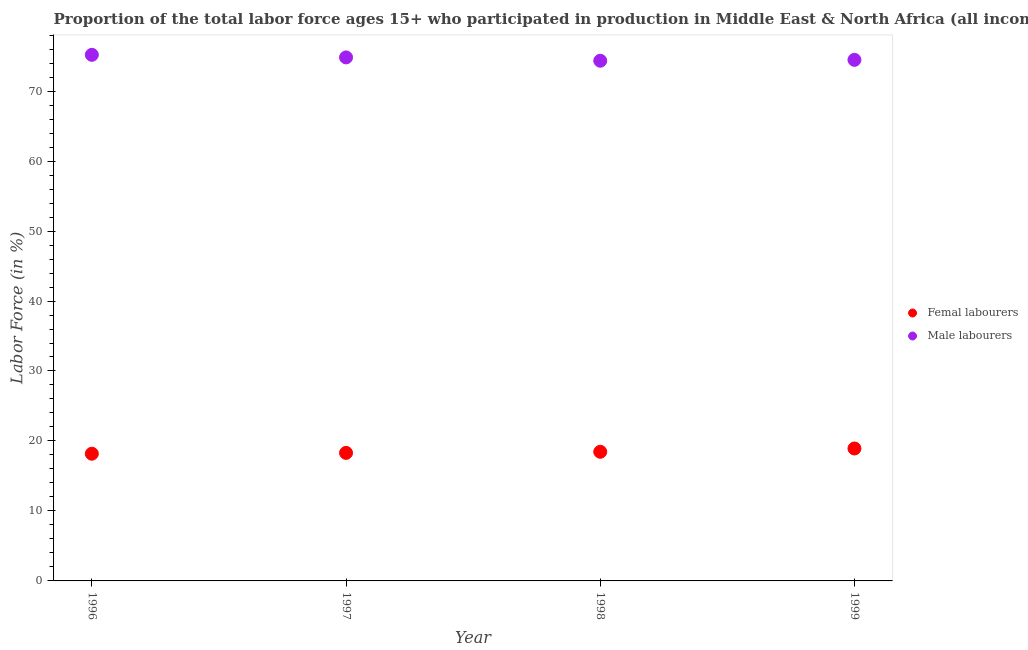Is the number of dotlines equal to the number of legend labels?
Provide a succinct answer. Yes. What is the percentage of female labor force in 1999?
Offer a very short reply. 18.93. Across all years, what is the maximum percentage of female labor force?
Ensure brevity in your answer.  18.93. Across all years, what is the minimum percentage of male labour force?
Provide a short and direct response. 74.34. In which year was the percentage of female labor force maximum?
Give a very brief answer. 1999. What is the total percentage of male labour force in the graph?
Offer a very short reply. 298.79. What is the difference between the percentage of female labor force in 1996 and that in 1998?
Ensure brevity in your answer.  -0.28. What is the difference between the percentage of female labor force in 1997 and the percentage of male labour force in 1999?
Offer a very short reply. -56.17. What is the average percentage of male labour force per year?
Make the answer very short. 74.7. In the year 1998, what is the difference between the percentage of male labour force and percentage of female labor force?
Make the answer very short. 55.88. What is the ratio of the percentage of male labour force in 1997 to that in 1998?
Provide a short and direct response. 1.01. Is the difference between the percentage of female labor force in 1996 and 1997 greater than the difference between the percentage of male labour force in 1996 and 1997?
Offer a very short reply. No. What is the difference between the highest and the second highest percentage of male labour force?
Your answer should be compact. 0.37. What is the difference between the highest and the lowest percentage of male labour force?
Provide a short and direct response. 0.85. Is the percentage of male labour force strictly greater than the percentage of female labor force over the years?
Your answer should be compact. Yes. How many dotlines are there?
Offer a very short reply. 2. Are the values on the major ticks of Y-axis written in scientific E-notation?
Make the answer very short. No. Does the graph contain any zero values?
Give a very brief answer. No. How many legend labels are there?
Provide a short and direct response. 2. What is the title of the graph?
Offer a terse response. Proportion of the total labor force ages 15+ who participated in production in Middle East & North Africa (all income levels). What is the label or title of the X-axis?
Ensure brevity in your answer.  Year. What is the Labor Force (in %) in Femal labourers in 1996?
Your answer should be compact. 18.18. What is the Labor Force (in %) in Male labourers in 1996?
Offer a terse response. 75.18. What is the Labor Force (in %) of Femal labourers in 1997?
Your answer should be compact. 18.3. What is the Labor Force (in %) of Male labourers in 1997?
Offer a terse response. 74.81. What is the Labor Force (in %) of Femal labourers in 1998?
Keep it short and to the point. 18.45. What is the Labor Force (in %) in Male labourers in 1998?
Offer a terse response. 74.34. What is the Labor Force (in %) in Femal labourers in 1999?
Your answer should be very brief. 18.93. What is the Labor Force (in %) of Male labourers in 1999?
Offer a terse response. 74.46. Across all years, what is the maximum Labor Force (in %) of Femal labourers?
Provide a short and direct response. 18.93. Across all years, what is the maximum Labor Force (in %) of Male labourers?
Make the answer very short. 75.18. Across all years, what is the minimum Labor Force (in %) of Femal labourers?
Your response must be concise. 18.18. Across all years, what is the minimum Labor Force (in %) in Male labourers?
Your response must be concise. 74.34. What is the total Labor Force (in %) in Femal labourers in the graph?
Make the answer very short. 73.86. What is the total Labor Force (in %) of Male labourers in the graph?
Provide a succinct answer. 298.79. What is the difference between the Labor Force (in %) of Femal labourers in 1996 and that in 1997?
Your answer should be compact. -0.12. What is the difference between the Labor Force (in %) of Male labourers in 1996 and that in 1997?
Provide a short and direct response. 0.37. What is the difference between the Labor Force (in %) of Femal labourers in 1996 and that in 1998?
Offer a terse response. -0.28. What is the difference between the Labor Force (in %) in Male labourers in 1996 and that in 1998?
Give a very brief answer. 0.85. What is the difference between the Labor Force (in %) in Femal labourers in 1996 and that in 1999?
Provide a succinct answer. -0.75. What is the difference between the Labor Force (in %) of Male labourers in 1996 and that in 1999?
Provide a short and direct response. 0.72. What is the difference between the Labor Force (in %) of Femal labourers in 1997 and that in 1998?
Your answer should be very brief. -0.16. What is the difference between the Labor Force (in %) of Male labourers in 1997 and that in 1998?
Make the answer very short. 0.48. What is the difference between the Labor Force (in %) in Femal labourers in 1997 and that in 1999?
Ensure brevity in your answer.  -0.63. What is the difference between the Labor Force (in %) of Male labourers in 1997 and that in 1999?
Offer a terse response. 0.35. What is the difference between the Labor Force (in %) of Femal labourers in 1998 and that in 1999?
Your answer should be compact. -0.47. What is the difference between the Labor Force (in %) of Male labourers in 1998 and that in 1999?
Provide a succinct answer. -0.13. What is the difference between the Labor Force (in %) in Femal labourers in 1996 and the Labor Force (in %) in Male labourers in 1997?
Your response must be concise. -56.63. What is the difference between the Labor Force (in %) in Femal labourers in 1996 and the Labor Force (in %) in Male labourers in 1998?
Make the answer very short. -56.16. What is the difference between the Labor Force (in %) of Femal labourers in 1996 and the Labor Force (in %) of Male labourers in 1999?
Offer a very short reply. -56.28. What is the difference between the Labor Force (in %) in Femal labourers in 1997 and the Labor Force (in %) in Male labourers in 1998?
Provide a short and direct response. -56.04. What is the difference between the Labor Force (in %) in Femal labourers in 1997 and the Labor Force (in %) in Male labourers in 1999?
Give a very brief answer. -56.17. What is the difference between the Labor Force (in %) in Femal labourers in 1998 and the Labor Force (in %) in Male labourers in 1999?
Provide a short and direct response. -56.01. What is the average Labor Force (in %) of Femal labourers per year?
Your answer should be very brief. 18.46. What is the average Labor Force (in %) of Male labourers per year?
Provide a succinct answer. 74.7. In the year 1996, what is the difference between the Labor Force (in %) in Femal labourers and Labor Force (in %) in Male labourers?
Provide a short and direct response. -57. In the year 1997, what is the difference between the Labor Force (in %) of Femal labourers and Labor Force (in %) of Male labourers?
Offer a very short reply. -56.51. In the year 1998, what is the difference between the Labor Force (in %) of Femal labourers and Labor Force (in %) of Male labourers?
Your response must be concise. -55.88. In the year 1999, what is the difference between the Labor Force (in %) in Femal labourers and Labor Force (in %) in Male labourers?
Your answer should be very brief. -55.54. What is the ratio of the Labor Force (in %) in Male labourers in 1996 to that in 1997?
Ensure brevity in your answer.  1. What is the ratio of the Labor Force (in %) of Femal labourers in 1996 to that in 1998?
Give a very brief answer. 0.99. What is the ratio of the Labor Force (in %) in Male labourers in 1996 to that in 1998?
Provide a succinct answer. 1.01. What is the ratio of the Labor Force (in %) in Femal labourers in 1996 to that in 1999?
Your answer should be compact. 0.96. What is the ratio of the Labor Force (in %) in Male labourers in 1996 to that in 1999?
Offer a very short reply. 1.01. What is the ratio of the Labor Force (in %) of Femal labourers in 1997 to that in 1998?
Make the answer very short. 0.99. What is the ratio of the Labor Force (in %) of Male labourers in 1997 to that in 1998?
Ensure brevity in your answer.  1.01. What is the ratio of the Labor Force (in %) in Femal labourers in 1997 to that in 1999?
Make the answer very short. 0.97. What is the ratio of the Labor Force (in %) of Male labourers in 1997 to that in 1999?
Provide a succinct answer. 1. What is the ratio of the Labor Force (in %) in Femal labourers in 1998 to that in 1999?
Make the answer very short. 0.97. What is the difference between the highest and the second highest Labor Force (in %) of Femal labourers?
Keep it short and to the point. 0.47. What is the difference between the highest and the second highest Labor Force (in %) of Male labourers?
Offer a very short reply. 0.37. What is the difference between the highest and the lowest Labor Force (in %) in Femal labourers?
Provide a short and direct response. 0.75. What is the difference between the highest and the lowest Labor Force (in %) of Male labourers?
Your answer should be very brief. 0.85. 